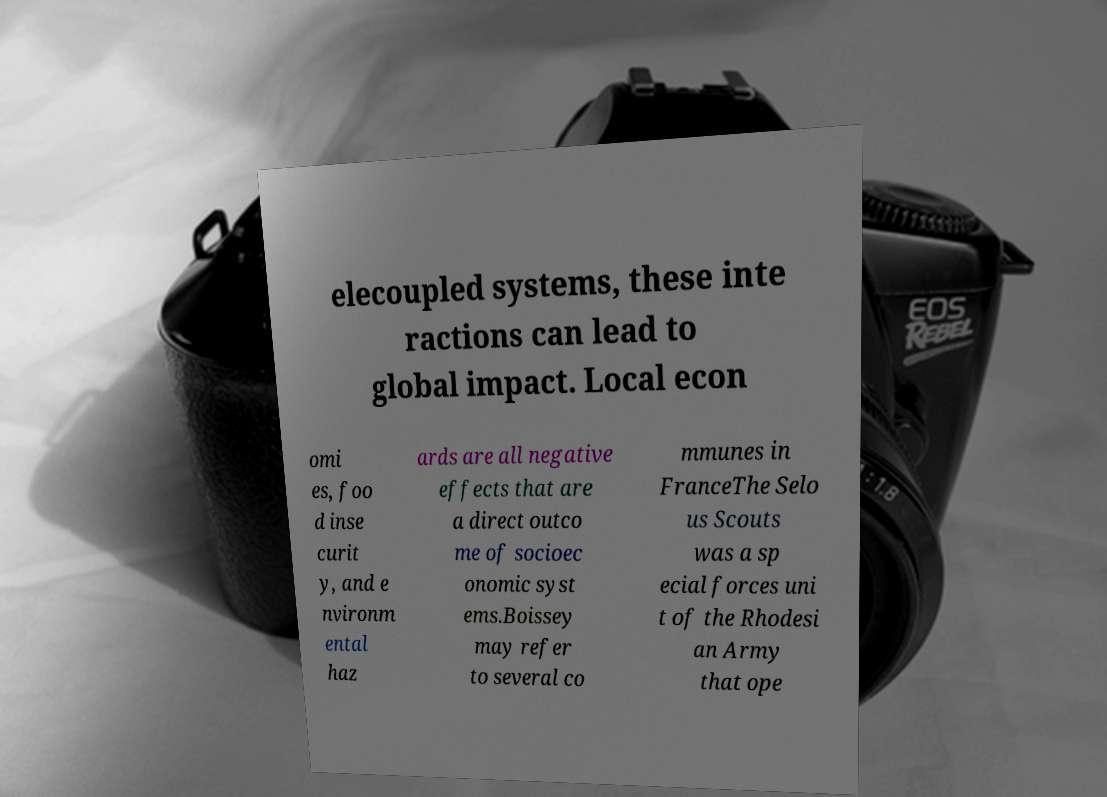There's text embedded in this image that I need extracted. Can you transcribe it verbatim? elecoupled systems, these inte ractions can lead to global impact. Local econ omi es, foo d inse curit y, and e nvironm ental haz ards are all negative effects that are a direct outco me of socioec onomic syst ems.Boissey may refer to several co mmunes in FranceThe Selo us Scouts was a sp ecial forces uni t of the Rhodesi an Army that ope 